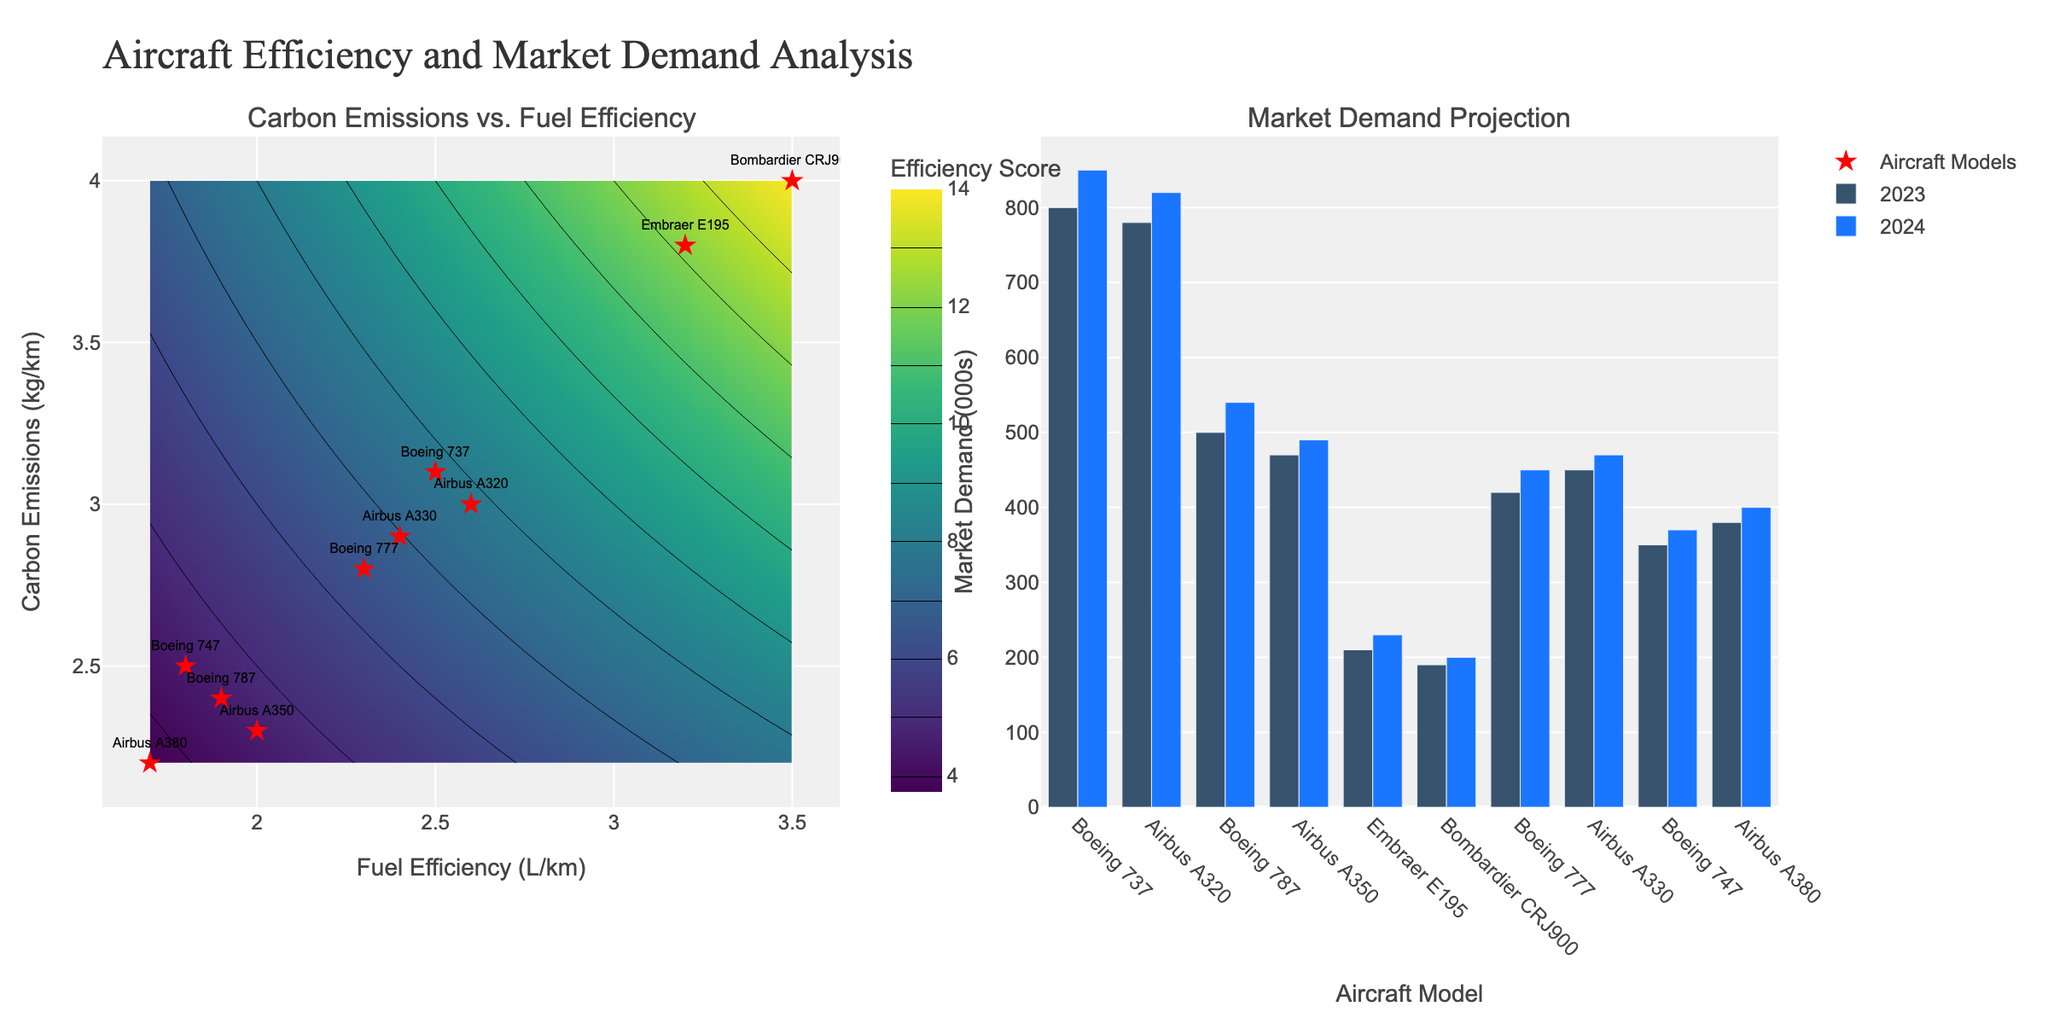What is the title of the figure? The title is displayed at the top of the figure. It reads "Aircraft Efficiency and Market Demand Analysis."
Answer: Aircraft Efficiency and Market Demand Analysis What are the colors used in the contour plot representing Efficiency Score? The colors used are part of the 'Viridis' color scale, which progresses through shades of purple, blue, green, and yellow.
Answer: Viridis color scale (purple, blue, green, yellow) Which aircraft model shows the highest fuel efficiency? Among the data points marked on the contour plot, the 'Airbus A380' has the lowest x-value (Fuel Efficiency), indicating the highest fuel efficiency.
Answer: Airbus A380 What is the projected market demand in 2024 for Airbus A320? By examining the bar chart on the right subplot, the bar representing the 'Airbus A320' for 2024 reaches the value of 820,000.
Answer: 820,000 How many aircraft models have a carbon emission of 3.0 kg/km or below? From the scatter plot on the left, we can count the number of points whose y-value (Carbon Emissions) is 3.0 or below. The models are 'Airbus A320', 'Boeing 787', 'Airbus A350', 'Boeing 777', 'Airbus A330', 'Boeing 747', and 'Airbus A380'. There are 7 models.
Answer: 7 What is the difference in market demand for Boeing 737 between 2023 and 2024? Referring to the height of the bars for 'Boeing 737' in 2023 and 2024, the values are 800,000 and 850,000, respectively. The difference is 850,000 - 800,000 = 50,000.
Answer: 50,000 Which aircraft model has the highest carbon emission and what is its market demand in 2023? The highest y-value in the scatter plot corresponds to 'Bombardier CRJ900'. Looking at the bar chart, the market demand for 'Bombardier CRJ900' in 2023 is 190,000.
Answer: Bombardier CRJ900, 190,000 What is the average carbon emission for Airbus models? The Airbus models are A320, A350, A330, and A380. Their carbon emissions are 3.0, 2.3, 2.9, and 2.2 respectively. The average is (3.0 + 2.3 + 2.9 + 2.2) / 4 = 2.6 kg/km.
Answer: 2.6 kg/km Which aircraft model has the highest projected market demand growth from 2023 to 2024? By subtracting the market demand in 2023 from that in 2024 for each model, we find the growth. The largest difference is between 'Boeing 737' with an increase from 800,000 to 850,000, which is 50,000.
Answer: Boeing 737 Which aircraft model has the best combination of low carbon emissions and high fuel efficiency, based on the scatter plot? The best combination will be indicated by the lowest values on both axes. 'Airbus A380' has the lowest values for both fuel efficiency (1.7 L/km) and carbon emissions (2.2 kg/km).
Answer: Airbus A380 